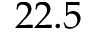Convert formula to latex. <formula><loc_0><loc_0><loc_500><loc_500>2 2 . 5</formula> 